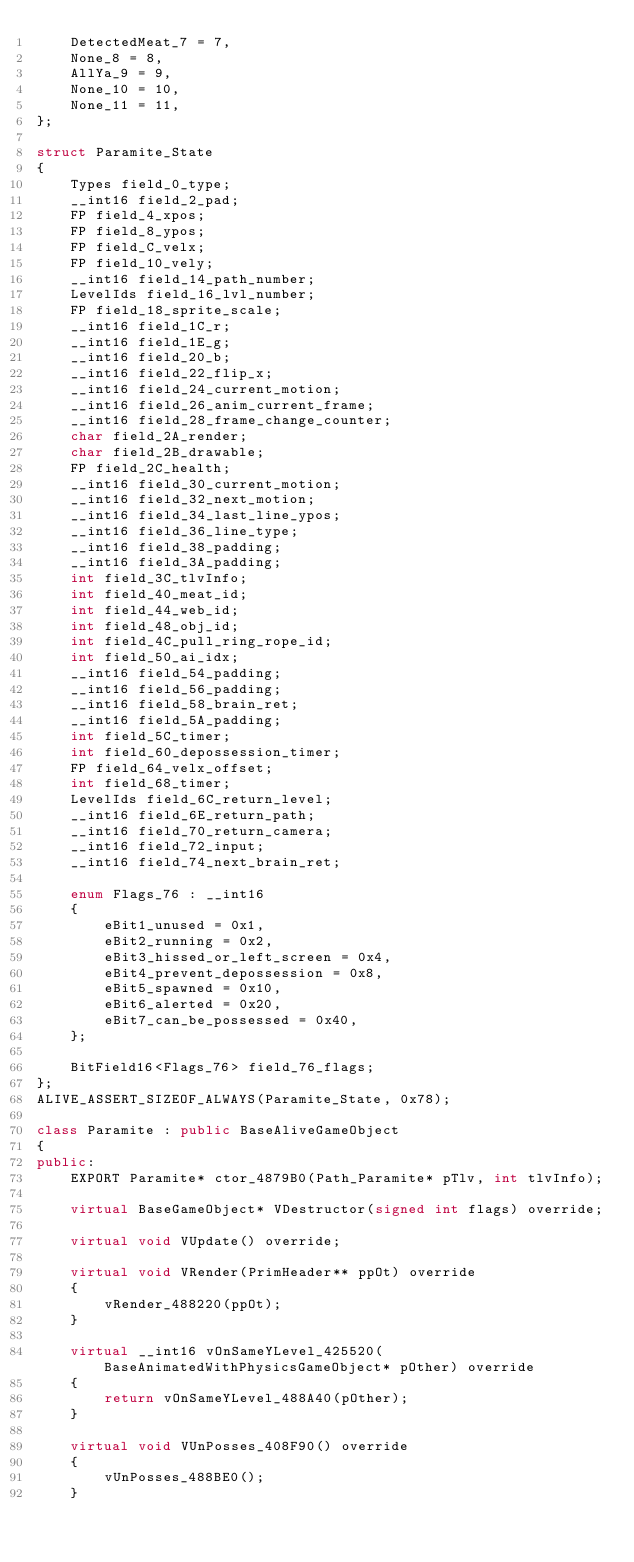<code> <loc_0><loc_0><loc_500><loc_500><_C++_>    DetectedMeat_7 = 7,
    None_8 = 8,
    AllYa_9 = 9,
    None_10 = 10,
    None_11 = 11,
};

struct Paramite_State
{
    Types field_0_type;
    __int16 field_2_pad;
    FP field_4_xpos;
    FP field_8_ypos;
    FP field_C_velx;
    FP field_10_vely;
    __int16 field_14_path_number;
    LevelIds field_16_lvl_number;
    FP field_18_sprite_scale;
    __int16 field_1C_r;
    __int16 field_1E_g;
    __int16 field_20_b;
    __int16 field_22_flip_x;
    __int16 field_24_current_motion;
    __int16 field_26_anim_current_frame;
    __int16 field_28_frame_change_counter;
    char field_2A_render;
    char field_2B_drawable;
    FP field_2C_health;
    __int16 field_30_current_motion;
    __int16 field_32_next_motion;
    __int16 field_34_last_line_ypos;
    __int16 field_36_line_type;
    __int16 field_38_padding;
    __int16 field_3A_padding;
    int field_3C_tlvInfo;
    int field_40_meat_id;
    int field_44_web_id;
    int field_48_obj_id;
    int field_4C_pull_ring_rope_id;
    int field_50_ai_idx;
    __int16 field_54_padding;
    __int16 field_56_padding;
    __int16 field_58_brain_ret;
    __int16 field_5A_padding;
    int field_5C_timer;
    int field_60_depossession_timer;
    FP field_64_velx_offset;
    int field_68_timer;
    LevelIds field_6C_return_level;
    __int16 field_6E_return_path;
    __int16 field_70_return_camera;
    __int16 field_72_input;
    __int16 field_74_next_brain_ret;

    enum Flags_76 : __int16
    {
        eBit1_unused = 0x1,
        eBit2_running = 0x2,
        eBit3_hissed_or_left_screen = 0x4,
        eBit4_prevent_depossession = 0x8,
        eBit5_spawned = 0x10,
        eBit6_alerted = 0x20,
        eBit7_can_be_possessed = 0x40,
    };

    BitField16<Flags_76> field_76_flags;
};
ALIVE_ASSERT_SIZEOF_ALWAYS(Paramite_State, 0x78);

class Paramite : public BaseAliveGameObject
{
public:
    EXPORT Paramite* ctor_4879B0(Path_Paramite* pTlv, int tlvInfo);

    virtual BaseGameObject* VDestructor(signed int flags) override;

    virtual void VUpdate() override;

    virtual void VRender(PrimHeader** ppOt) override
    {
        vRender_488220(ppOt);
    }

    virtual __int16 vOnSameYLevel_425520(BaseAnimatedWithPhysicsGameObject* pOther) override
    {
        return vOnSameYLevel_488A40(pOther);
    }

    virtual void VUnPosses_408F90() override
    {
        vUnPosses_488BE0();
    }
</code> 